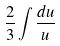<formula> <loc_0><loc_0><loc_500><loc_500>\frac { 2 } { 3 } \int \frac { d u } { u }</formula> 